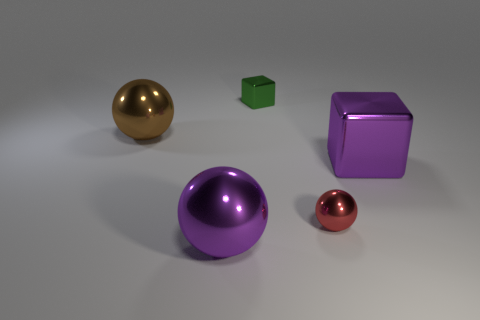Add 2 tiny cylinders. How many objects exist? 7 Subtract all blocks. How many objects are left? 3 Add 5 purple balls. How many purple balls exist? 6 Subtract 0 blue blocks. How many objects are left? 5 Subtract all blue matte cylinders. Subtract all purple spheres. How many objects are left? 4 Add 2 large metallic cubes. How many large metallic cubes are left? 3 